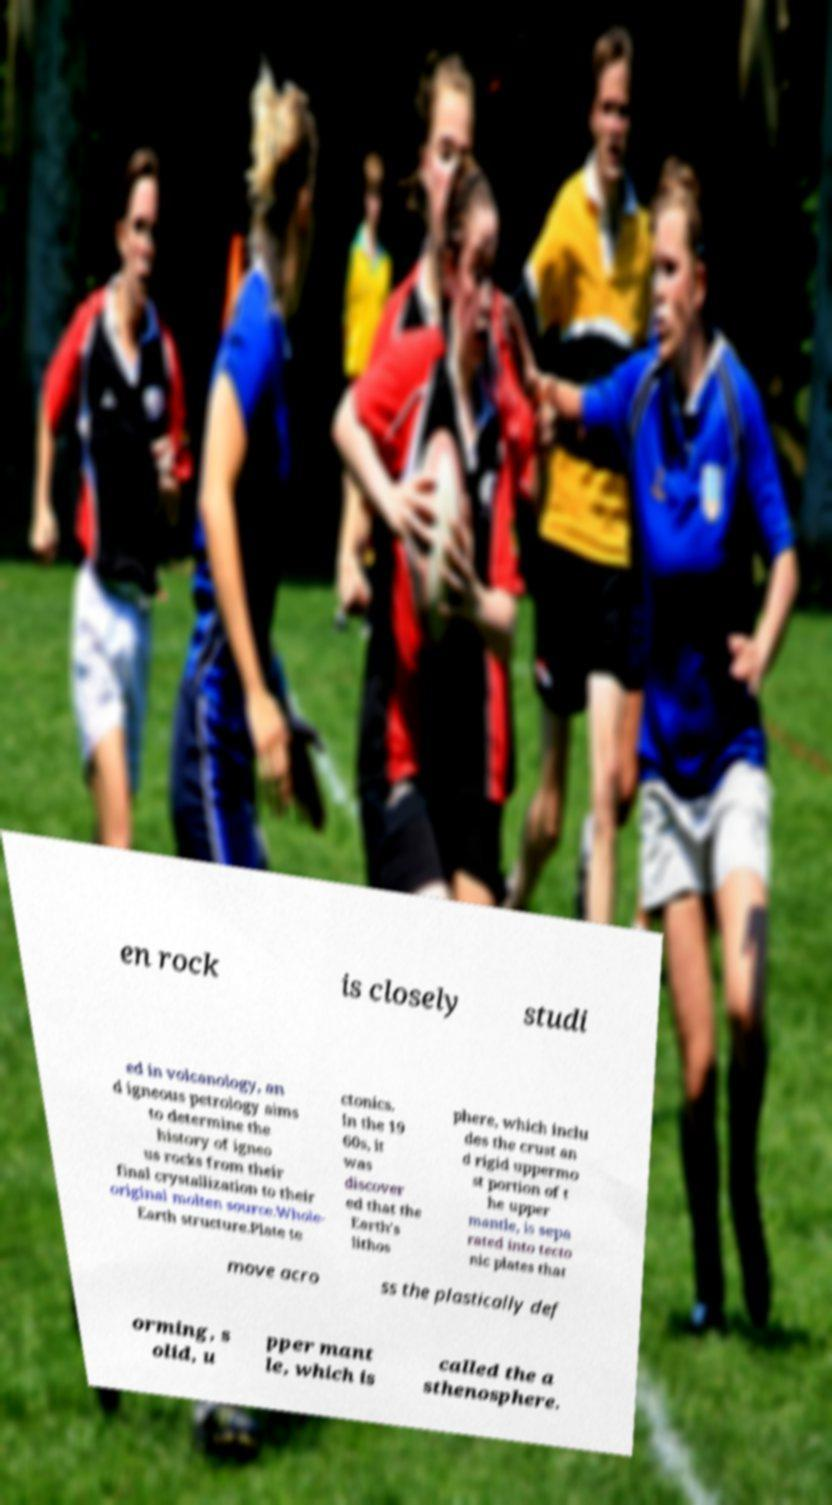Please identify and transcribe the text found in this image. en rock is closely studi ed in volcanology, an d igneous petrology aims to determine the history of igneo us rocks from their final crystallization to their original molten source.Whole- Earth structure.Plate te ctonics. In the 19 60s, it was discover ed that the Earth's lithos phere, which inclu des the crust an d rigid uppermo st portion of t he upper mantle, is sepa rated into tecto nic plates that move acro ss the plastically def orming, s olid, u pper mant le, which is called the a sthenosphere. 